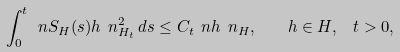<formula> <loc_0><loc_0><loc_500><loc_500>\int ^ { t } _ { 0 } \ n S _ { H } ( s ) h \ n _ { H _ { t } } ^ { 2 } \, d s \leq C _ { t } \ n h \ n _ { H } , \quad h \in H , \ \ t > 0 ,</formula> 